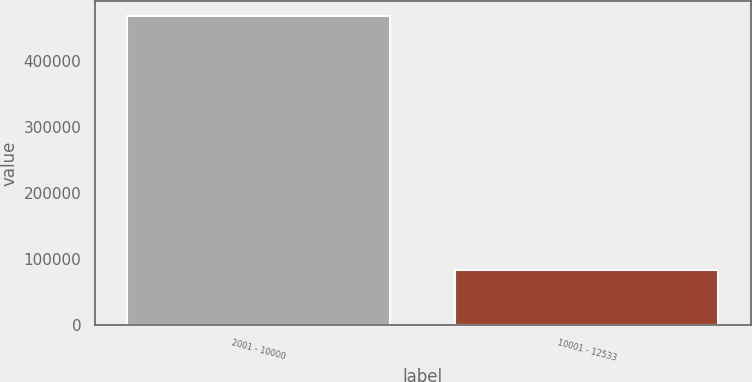<chart> <loc_0><loc_0><loc_500><loc_500><bar_chart><fcel>2001 - 10000<fcel>10001 - 12533<nl><fcel>467430<fcel>82857<nl></chart> 